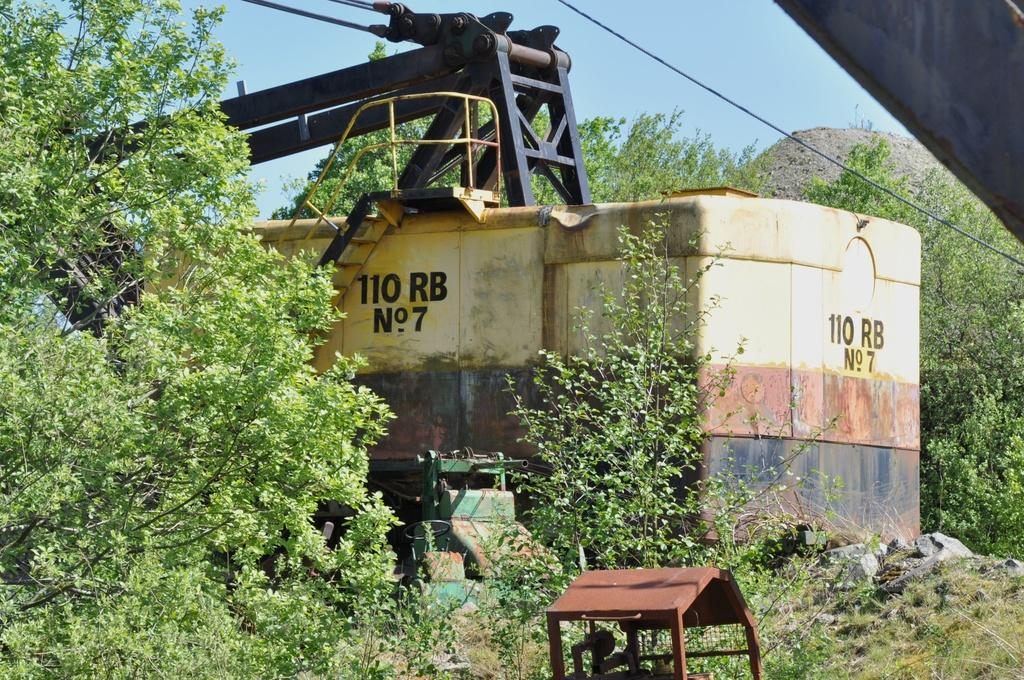What is the main subject of the image? There is a machine in the image. Can you describe the brown object in the image? There is a brown object in the image. What can be seen in the background of the image? There are trees in the background of the image. What type of advice can be heard coming from the machine in the image? There is no indication in the image that the machine is providing advice or any form of communication. 